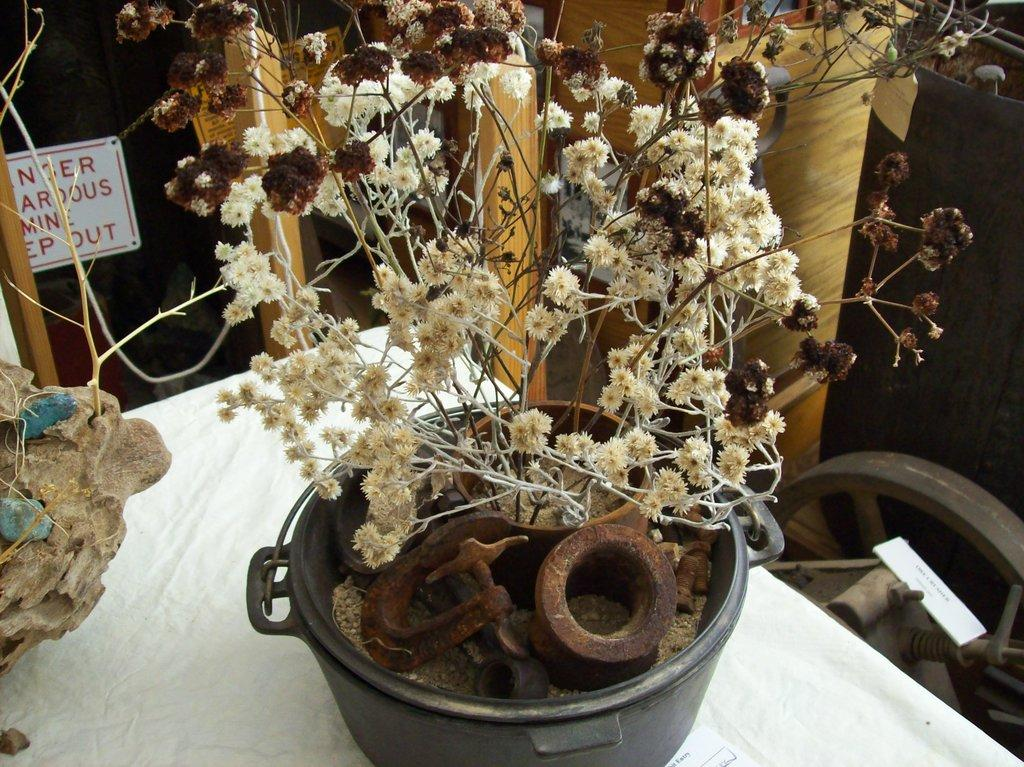What objects are on the table in the image? There are planets on the table in the image. What can be seen in the background of the image? There are cupboards in the background of the image. How does the girl in the image compare the size of the planets? There is no girl present in the image, so it is not possible to answer a question about her comparing the size of the planets. 